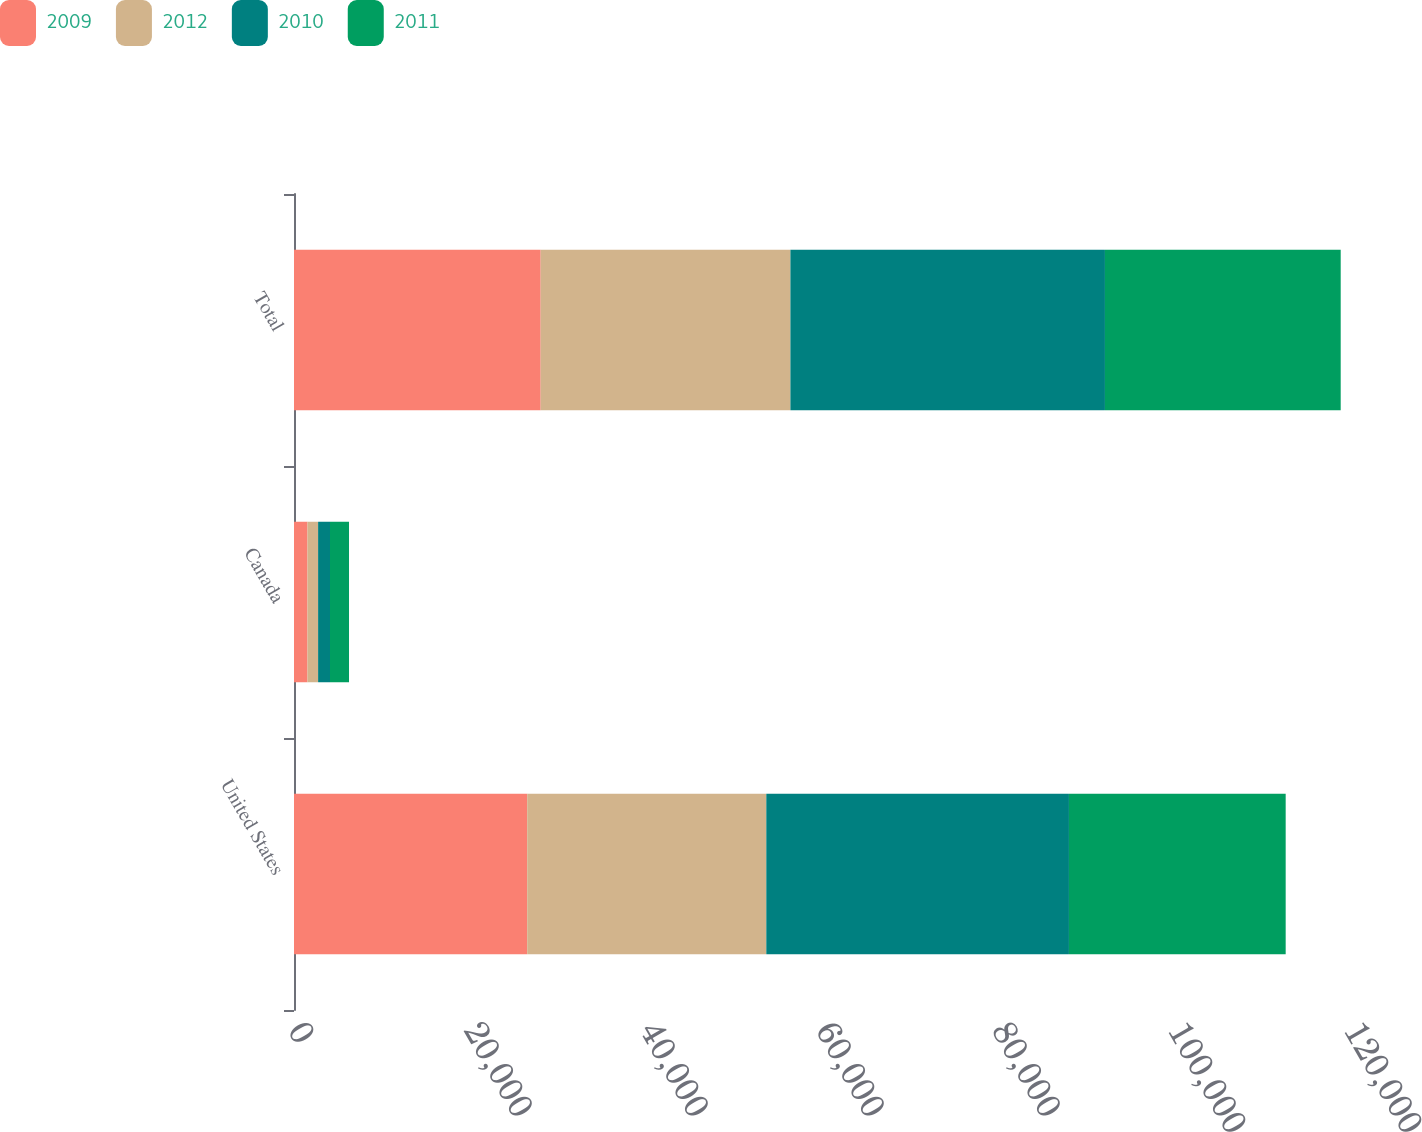Convert chart to OTSL. <chart><loc_0><loc_0><loc_500><loc_500><stacked_bar_chart><ecel><fcel>United States<fcel>Canada<fcel>Total<nl><fcel>2009<fcel>26500<fcel>1533<fcel>28033<nl><fcel>2012<fcel>27171<fcel>1207<fcel>28378<nl><fcel>2010<fcel>34391<fcel>1351<fcel>35742<nl><fcel>2011<fcel>24629<fcel>2161<fcel>26790<nl></chart> 